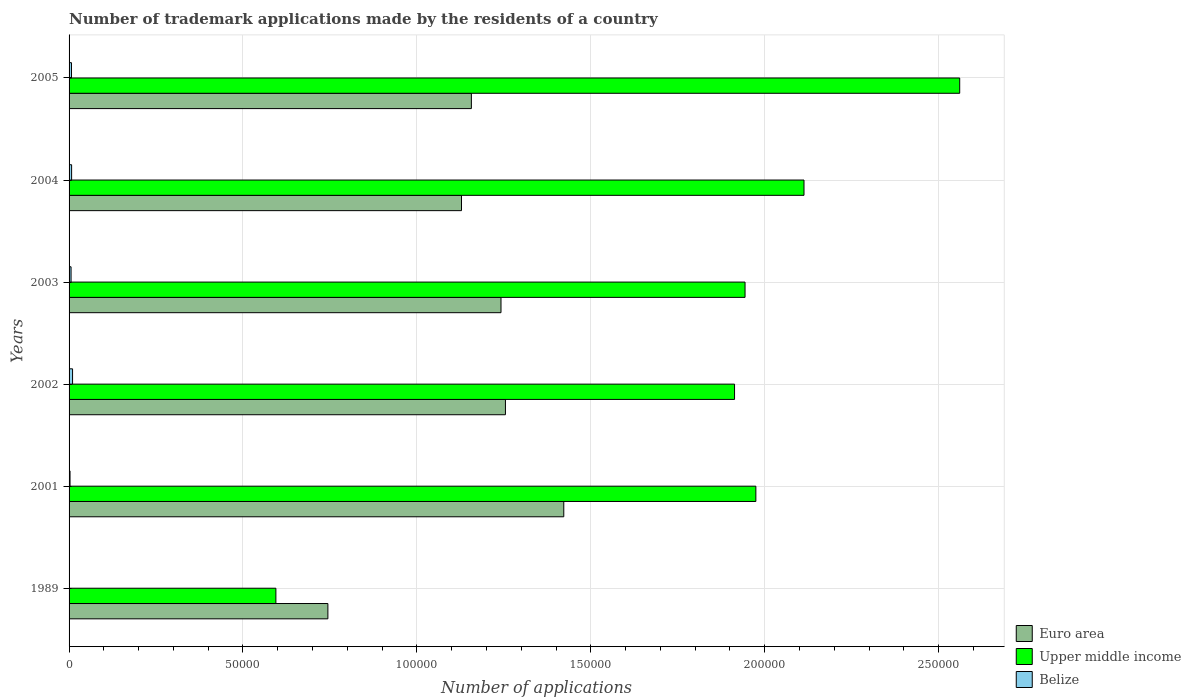How many different coloured bars are there?
Give a very brief answer. 3. How many groups of bars are there?
Keep it short and to the point. 6. Are the number of bars per tick equal to the number of legend labels?
Offer a very short reply. Yes. How many bars are there on the 4th tick from the bottom?
Ensure brevity in your answer.  3. What is the label of the 4th group of bars from the top?
Provide a short and direct response. 2002. In how many cases, is the number of bars for a given year not equal to the number of legend labels?
Provide a short and direct response. 0. What is the number of trademark applications made by the residents in Belize in 2002?
Your answer should be very brief. 1002. Across all years, what is the maximum number of trademark applications made by the residents in Upper middle income?
Your answer should be very brief. 2.56e+05. Across all years, what is the minimum number of trademark applications made by the residents in Euro area?
Ensure brevity in your answer.  7.44e+04. In which year was the number of trademark applications made by the residents in Belize maximum?
Your answer should be compact. 2002. In which year was the number of trademark applications made by the residents in Euro area minimum?
Offer a terse response. 1989. What is the total number of trademark applications made by the residents in Belize in the graph?
Give a very brief answer. 3315. What is the difference between the number of trademark applications made by the residents in Euro area in 2004 and that in 2005?
Keep it short and to the point. -2840. What is the difference between the number of trademark applications made by the residents in Euro area in 1989 and the number of trademark applications made by the residents in Belize in 2001?
Your answer should be very brief. 7.41e+04. What is the average number of trademark applications made by the residents in Belize per year?
Make the answer very short. 552.5. In the year 2002, what is the difference between the number of trademark applications made by the residents in Upper middle income and number of trademark applications made by the residents in Belize?
Ensure brevity in your answer.  1.90e+05. What is the ratio of the number of trademark applications made by the residents in Belize in 1989 to that in 2003?
Give a very brief answer. 0.07. What is the difference between the highest and the second highest number of trademark applications made by the residents in Upper middle income?
Offer a very short reply. 4.48e+04. What is the difference between the highest and the lowest number of trademark applications made by the residents in Upper middle income?
Give a very brief answer. 1.97e+05. What does the 1st bar from the top in 2004 represents?
Offer a very short reply. Belize. What does the 3rd bar from the bottom in 2004 represents?
Give a very brief answer. Belize. Is it the case that in every year, the sum of the number of trademark applications made by the residents in Belize and number of trademark applications made by the residents in Upper middle income is greater than the number of trademark applications made by the residents in Euro area?
Your answer should be compact. No. What is the difference between two consecutive major ticks on the X-axis?
Keep it short and to the point. 5.00e+04. Are the values on the major ticks of X-axis written in scientific E-notation?
Offer a terse response. No. Does the graph contain any zero values?
Offer a terse response. No. How many legend labels are there?
Provide a succinct answer. 3. What is the title of the graph?
Keep it short and to the point. Number of trademark applications made by the residents of a country. What is the label or title of the X-axis?
Give a very brief answer. Number of applications. What is the label or title of the Y-axis?
Offer a terse response. Years. What is the Number of applications of Euro area in 1989?
Provide a short and direct response. 7.44e+04. What is the Number of applications of Upper middle income in 1989?
Offer a terse response. 5.95e+04. What is the Number of applications of Euro area in 2001?
Provide a short and direct response. 1.42e+05. What is the Number of applications in Upper middle income in 2001?
Offer a very short reply. 1.97e+05. What is the Number of applications of Belize in 2001?
Your answer should be very brief. 277. What is the Number of applications of Euro area in 2002?
Offer a very short reply. 1.25e+05. What is the Number of applications of Upper middle income in 2002?
Give a very brief answer. 1.91e+05. What is the Number of applications in Belize in 2002?
Offer a very short reply. 1002. What is the Number of applications of Euro area in 2003?
Your response must be concise. 1.24e+05. What is the Number of applications in Upper middle income in 2003?
Give a very brief answer. 1.94e+05. What is the Number of applications of Belize in 2003?
Your answer should be compact. 573. What is the Number of applications in Euro area in 2004?
Provide a short and direct response. 1.13e+05. What is the Number of applications of Upper middle income in 2004?
Your answer should be very brief. 2.11e+05. What is the Number of applications of Belize in 2004?
Your response must be concise. 732. What is the Number of applications in Euro area in 2005?
Provide a short and direct response. 1.16e+05. What is the Number of applications of Upper middle income in 2005?
Provide a succinct answer. 2.56e+05. What is the Number of applications of Belize in 2005?
Provide a short and direct response. 693. Across all years, what is the maximum Number of applications in Euro area?
Provide a succinct answer. 1.42e+05. Across all years, what is the maximum Number of applications of Upper middle income?
Make the answer very short. 2.56e+05. Across all years, what is the maximum Number of applications in Belize?
Make the answer very short. 1002. Across all years, what is the minimum Number of applications in Euro area?
Make the answer very short. 7.44e+04. Across all years, what is the minimum Number of applications in Upper middle income?
Your answer should be very brief. 5.95e+04. What is the total Number of applications in Euro area in the graph?
Keep it short and to the point. 6.95e+05. What is the total Number of applications in Upper middle income in the graph?
Your answer should be compact. 1.11e+06. What is the total Number of applications in Belize in the graph?
Offer a very short reply. 3315. What is the difference between the Number of applications of Euro area in 1989 and that in 2001?
Offer a very short reply. -6.78e+04. What is the difference between the Number of applications of Upper middle income in 1989 and that in 2001?
Provide a succinct answer. -1.38e+05. What is the difference between the Number of applications in Belize in 1989 and that in 2001?
Keep it short and to the point. -239. What is the difference between the Number of applications of Euro area in 1989 and that in 2002?
Give a very brief answer. -5.10e+04. What is the difference between the Number of applications of Upper middle income in 1989 and that in 2002?
Offer a terse response. -1.32e+05. What is the difference between the Number of applications in Belize in 1989 and that in 2002?
Your answer should be very brief. -964. What is the difference between the Number of applications of Euro area in 1989 and that in 2003?
Ensure brevity in your answer.  -4.98e+04. What is the difference between the Number of applications of Upper middle income in 1989 and that in 2003?
Your answer should be compact. -1.35e+05. What is the difference between the Number of applications in Belize in 1989 and that in 2003?
Your response must be concise. -535. What is the difference between the Number of applications of Euro area in 1989 and that in 2004?
Ensure brevity in your answer.  -3.84e+04. What is the difference between the Number of applications of Upper middle income in 1989 and that in 2004?
Offer a terse response. -1.52e+05. What is the difference between the Number of applications of Belize in 1989 and that in 2004?
Ensure brevity in your answer.  -694. What is the difference between the Number of applications in Euro area in 1989 and that in 2005?
Make the answer very short. -4.13e+04. What is the difference between the Number of applications in Upper middle income in 1989 and that in 2005?
Your answer should be very brief. -1.97e+05. What is the difference between the Number of applications in Belize in 1989 and that in 2005?
Give a very brief answer. -655. What is the difference between the Number of applications in Euro area in 2001 and that in 2002?
Provide a short and direct response. 1.68e+04. What is the difference between the Number of applications of Upper middle income in 2001 and that in 2002?
Give a very brief answer. 6129. What is the difference between the Number of applications in Belize in 2001 and that in 2002?
Provide a short and direct response. -725. What is the difference between the Number of applications of Euro area in 2001 and that in 2003?
Provide a succinct answer. 1.80e+04. What is the difference between the Number of applications in Upper middle income in 2001 and that in 2003?
Make the answer very short. 3108. What is the difference between the Number of applications in Belize in 2001 and that in 2003?
Your answer should be very brief. -296. What is the difference between the Number of applications in Euro area in 2001 and that in 2004?
Your answer should be compact. 2.94e+04. What is the difference between the Number of applications of Upper middle income in 2001 and that in 2004?
Ensure brevity in your answer.  -1.38e+04. What is the difference between the Number of applications of Belize in 2001 and that in 2004?
Your response must be concise. -455. What is the difference between the Number of applications of Euro area in 2001 and that in 2005?
Provide a short and direct response. 2.66e+04. What is the difference between the Number of applications of Upper middle income in 2001 and that in 2005?
Your response must be concise. -5.86e+04. What is the difference between the Number of applications in Belize in 2001 and that in 2005?
Your answer should be compact. -416. What is the difference between the Number of applications of Euro area in 2002 and that in 2003?
Your response must be concise. 1276. What is the difference between the Number of applications in Upper middle income in 2002 and that in 2003?
Your answer should be compact. -3021. What is the difference between the Number of applications in Belize in 2002 and that in 2003?
Offer a terse response. 429. What is the difference between the Number of applications in Euro area in 2002 and that in 2004?
Provide a short and direct response. 1.26e+04. What is the difference between the Number of applications in Upper middle income in 2002 and that in 2004?
Provide a short and direct response. -2.00e+04. What is the difference between the Number of applications of Belize in 2002 and that in 2004?
Provide a short and direct response. 270. What is the difference between the Number of applications in Euro area in 2002 and that in 2005?
Provide a short and direct response. 9790. What is the difference between the Number of applications of Upper middle income in 2002 and that in 2005?
Give a very brief answer. -6.47e+04. What is the difference between the Number of applications in Belize in 2002 and that in 2005?
Offer a terse response. 309. What is the difference between the Number of applications of Euro area in 2003 and that in 2004?
Your answer should be compact. 1.14e+04. What is the difference between the Number of applications of Upper middle income in 2003 and that in 2004?
Provide a succinct answer. -1.69e+04. What is the difference between the Number of applications in Belize in 2003 and that in 2004?
Make the answer very short. -159. What is the difference between the Number of applications of Euro area in 2003 and that in 2005?
Provide a short and direct response. 8514. What is the difference between the Number of applications in Upper middle income in 2003 and that in 2005?
Your answer should be very brief. -6.17e+04. What is the difference between the Number of applications of Belize in 2003 and that in 2005?
Make the answer very short. -120. What is the difference between the Number of applications in Euro area in 2004 and that in 2005?
Provide a succinct answer. -2840. What is the difference between the Number of applications of Upper middle income in 2004 and that in 2005?
Ensure brevity in your answer.  -4.48e+04. What is the difference between the Number of applications of Belize in 2004 and that in 2005?
Give a very brief answer. 39. What is the difference between the Number of applications in Euro area in 1989 and the Number of applications in Upper middle income in 2001?
Offer a terse response. -1.23e+05. What is the difference between the Number of applications of Euro area in 1989 and the Number of applications of Belize in 2001?
Offer a terse response. 7.41e+04. What is the difference between the Number of applications of Upper middle income in 1989 and the Number of applications of Belize in 2001?
Ensure brevity in your answer.  5.92e+04. What is the difference between the Number of applications in Euro area in 1989 and the Number of applications in Upper middle income in 2002?
Keep it short and to the point. -1.17e+05. What is the difference between the Number of applications in Euro area in 1989 and the Number of applications in Belize in 2002?
Provide a succinct answer. 7.34e+04. What is the difference between the Number of applications of Upper middle income in 1989 and the Number of applications of Belize in 2002?
Give a very brief answer. 5.85e+04. What is the difference between the Number of applications of Euro area in 1989 and the Number of applications of Upper middle income in 2003?
Your answer should be compact. -1.20e+05. What is the difference between the Number of applications in Euro area in 1989 and the Number of applications in Belize in 2003?
Your response must be concise. 7.38e+04. What is the difference between the Number of applications of Upper middle income in 1989 and the Number of applications of Belize in 2003?
Your answer should be very brief. 5.89e+04. What is the difference between the Number of applications in Euro area in 1989 and the Number of applications in Upper middle income in 2004?
Your answer should be compact. -1.37e+05. What is the difference between the Number of applications in Euro area in 1989 and the Number of applications in Belize in 2004?
Offer a terse response. 7.37e+04. What is the difference between the Number of applications in Upper middle income in 1989 and the Number of applications in Belize in 2004?
Your answer should be very brief. 5.87e+04. What is the difference between the Number of applications of Euro area in 1989 and the Number of applications of Upper middle income in 2005?
Your answer should be very brief. -1.82e+05. What is the difference between the Number of applications of Euro area in 1989 and the Number of applications of Belize in 2005?
Offer a very short reply. 7.37e+04. What is the difference between the Number of applications of Upper middle income in 1989 and the Number of applications of Belize in 2005?
Your response must be concise. 5.88e+04. What is the difference between the Number of applications of Euro area in 2001 and the Number of applications of Upper middle income in 2002?
Ensure brevity in your answer.  -4.91e+04. What is the difference between the Number of applications of Euro area in 2001 and the Number of applications of Belize in 2002?
Give a very brief answer. 1.41e+05. What is the difference between the Number of applications of Upper middle income in 2001 and the Number of applications of Belize in 2002?
Your response must be concise. 1.96e+05. What is the difference between the Number of applications of Euro area in 2001 and the Number of applications of Upper middle income in 2003?
Make the answer very short. -5.21e+04. What is the difference between the Number of applications of Euro area in 2001 and the Number of applications of Belize in 2003?
Offer a terse response. 1.42e+05. What is the difference between the Number of applications in Upper middle income in 2001 and the Number of applications in Belize in 2003?
Offer a terse response. 1.97e+05. What is the difference between the Number of applications of Euro area in 2001 and the Number of applications of Upper middle income in 2004?
Offer a very short reply. -6.91e+04. What is the difference between the Number of applications in Euro area in 2001 and the Number of applications in Belize in 2004?
Your answer should be very brief. 1.41e+05. What is the difference between the Number of applications in Upper middle income in 2001 and the Number of applications in Belize in 2004?
Give a very brief answer. 1.97e+05. What is the difference between the Number of applications of Euro area in 2001 and the Number of applications of Upper middle income in 2005?
Offer a very short reply. -1.14e+05. What is the difference between the Number of applications of Euro area in 2001 and the Number of applications of Belize in 2005?
Offer a terse response. 1.42e+05. What is the difference between the Number of applications in Upper middle income in 2001 and the Number of applications in Belize in 2005?
Offer a very short reply. 1.97e+05. What is the difference between the Number of applications of Euro area in 2002 and the Number of applications of Upper middle income in 2003?
Provide a succinct answer. -6.89e+04. What is the difference between the Number of applications in Euro area in 2002 and the Number of applications in Belize in 2003?
Ensure brevity in your answer.  1.25e+05. What is the difference between the Number of applications in Upper middle income in 2002 and the Number of applications in Belize in 2003?
Give a very brief answer. 1.91e+05. What is the difference between the Number of applications of Euro area in 2002 and the Number of applications of Upper middle income in 2004?
Your answer should be compact. -8.58e+04. What is the difference between the Number of applications in Euro area in 2002 and the Number of applications in Belize in 2004?
Make the answer very short. 1.25e+05. What is the difference between the Number of applications in Upper middle income in 2002 and the Number of applications in Belize in 2004?
Give a very brief answer. 1.91e+05. What is the difference between the Number of applications in Euro area in 2002 and the Number of applications in Upper middle income in 2005?
Give a very brief answer. -1.31e+05. What is the difference between the Number of applications in Euro area in 2002 and the Number of applications in Belize in 2005?
Ensure brevity in your answer.  1.25e+05. What is the difference between the Number of applications in Upper middle income in 2002 and the Number of applications in Belize in 2005?
Your answer should be very brief. 1.91e+05. What is the difference between the Number of applications of Euro area in 2003 and the Number of applications of Upper middle income in 2004?
Provide a short and direct response. -8.71e+04. What is the difference between the Number of applications of Euro area in 2003 and the Number of applications of Belize in 2004?
Provide a short and direct response. 1.23e+05. What is the difference between the Number of applications in Upper middle income in 2003 and the Number of applications in Belize in 2004?
Provide a short and direct response. 1.94e+05. What is the difference between the Number of applications of Euro area in 2003 and the Number of applications of Upper middle income in 2005?
Make the answer very short. -1.32e+05. What is the difference between the Number of applications of Euro area in 2003 and the Number of applications of Belize in 2005?
Your answer should be very brief. 1.23e+05. What is the difference between the Number of applications in Upper middle income in 2003 and the Number of applications in Belize in 2005?
Your response must be concise. 1.94e+05. What is the difference between the Number of applications of Euro area in 2004 and the Number of applications of Upper middle income in 2005?
Ensure brevity in your answer.  -1.43e+05. What is the difference between the Number of applications of Euro area in 2004 and the Number of applications of Belize in 2005?
Ensure brevity in your answer.  1.12e+05. What is the difference between the Number of applications in Upper middle income in 2004 and the Number of applications in Belize in 2005?
Your response must be concise. 2.11e+05. What is the average Number of applications of Euro area per year?
Your answer should be very brief. 1.16e+05. What is the average Number of applications in Upper middle income per year?
Ensure brevity in your answer.  1.85e+05. What is the average Number of applications of Belize per year?
Your answer should be compact. 552.5. In the year 1989, what is the difference between the Number of applications of Euro area and Number of applications of Upper middle income?
Keep it short and to the point. 1.49e+04. In the year 1989, what is the difference between the Number of applications in Euro area and Number of applications in Belize?
Your answer should be compact. 7.44e+04. In the year 1989, what is the difference between the Number of applications in Upper middle income and Number of applications in Belize?
Give a very brief answer. 5.94e+04. In the year 2001, what is the difference between the Number of applications of Euro area and Number of applications of Upper middle income?
Your response must be concise. -5.52e+04. In the year 2001, what is the difference between the Number of applications of Euro area and Number of applications of Belize?
Your answer should be compact. 1.42e+05. In the year 2001, what is the difference between the Number of applications of Upper middle income and Number of applications of Belize?
Provide a short and direct response. 1.97e+05. In the year 2002, what is the difference between the Number of applications in Euro area and Number of applications in Upper middle income?
Ensure brevity in your answer.  -6.59e+04. In the year 2002, what is the difference between the Number of applications in Euro area and Number of applications in Belize?
Offer a very short reply. 1.24e+05. In the year 2002, what is the difference between the Number of applications of Upper middle income and Number of applications of Belize?
Provide a succinct answer. 1.90e+05. In the year 2003, what is the difference between the Number of applications in Euro area and Number of applications in Upper middle income?
Ensure brevity in your answer.  -7.02e+04. In the year 2003, what is the difference between the Number of applications of Euro area and Number of applications of Belize?
Your answer should be compact. 1.24e+05. In the year 2003, what is the difference between the Number of applications in Upper middle income and Number of applications in Belize?
Offer a very short reply. 1.94e+05. In the year 2004, what is the difference between the Number of applications in Euro area and Number of applications in Upper middle income?
Give a very brief answer. -9.85e+04. In the year 2004, what is the difference between the Number of applications in Euro area and Number of applications in Belize?
Offer a terse response. 1.12e+05. In the year 2004, what is the difference between the Number of applications of Upper middle income and Number of applications of Belize?
Give a very brief answer. 2.11e+05. In the year 2005, what is the difference between the Number of applications in Euro area and Number of applications in Upper middle income?
Ensure brevity in your answer.  -1.40e+05. In the year 2005, what is the difference between the Number of applications of Euro area and Number of applications of Belize?
Your response must be concise. 1.15e+05. In the year 2005, what is the difference between the Number of applications in Upper middle income and Number of applications in Belize?
Ensure brevity in your answer.  2.55e+05. What is the ratio of the Number of applications of Euro area in 1989 to that in 2001?
Your answer should be very brief. 0.52. What is the ratio of the Number of applications of Upper middle income in 1989 to that in 2001?
Your response must be concise. 0.3. What is the ratio of the Number of applications of Belize in 1989 to that in 2001?
Offer a terse response. 0.14. What is the ratio of the Number of applications of Euro area in 1989 to that in 2002?
Give a very brief answer. 0.59. What is the ratio of the Number of applications in Upper middle income in 1989 to that in 2002?
Your response must be concise. 0.31. What is the ratio of the Number of applications of Belize in 1989 to that in 2002?
Provide a succinct answer. 0.04. What is the ratio of the Number of applications in Euro area in 1989 to that in 2003?
Ensure brevity in your answer.  0.6. What is the ratio of the Number of applications in Upper middle income in 1989 to that in 2003?
Your response must be concise. 0.31. What is the ratio of the Number of applications in Belize in 1989 to that in 2003?
Your response must be concise. 0.07. What is the ratio of the Number of applications of Euro area in 1989 to that in 2004?
Give a very brief answer. 0.66. What is the ratio of the Number of applications in Upper middle income in 1989 to that in 2004?
Keep it short and to the point. 0.28. What is the ratio of the Number of applications of Belize in 1989 to that in 2004?
Offer a terse response. 0.05. What is the ratio of the Number of applications of Euro area in 1989 to that in 2005?
Provide a short and direct response. 0.64. What is the ratio of the Number of applications of Upper middle income in 1989 to that in 2005?
Your response must be concise. 0.23. What is the ratio of the Number of applications of Belize in 1989 to that in 2005?
Provide a succinct answer. 0.05. What is the ratio of the Number of applications in Euro area in 2001 to that in 2002?
Provide a short and direct response. 1.13. What is the ratio of the Number of applications of Upper middle income in 2001 to that in 2002?
Make the answer very short. 1.03. What is the ratio of the Number of applications of Belize in 2001 to that in 2002?
Keep it short and to the point. 0.28. What is the ratio of the Number of applications of Euro area in 2001 to that in 2003?
Your answer should be very brief. 1.15. What is the ratio of the Number of applications of Belize in 2001 to that in 2003?
Keep it short and to the point. 0.48. What is the ratio of the Number of applications in Euro area in 2001 to that in 2004?
Provide a succinct answer. 1.26. What is the ratio of the Number of applications in Upper middle income in 2001 to that in 2004?
Offer a very short reply. 0.93. What is the ratio of the Number of applications of Belize in 2001 to that in 2004?
Provide a succinct answer. 0.38. What is the ratio of the Number of applications in Euro area in 2001 to that in 2005?
Provide a short and direct response. 1.23. What is the ratio of the Number of applications of Upper middle income in 2001 to that in 2005?
Your answer should be very brief. 0.77. What is the ratio of the Number of applications in Belize in 2001 to that in 2005?
Your response must be concise. 0.4. What is the ratio of the Number of applications in Euro area in 2002 to that in 2003?
Provide a succinct answer. 1.01. What is the ratio of the Number of applications in Upper middle income in 2002 to that in 2003?
Keep it short and to the point. 0.98. What is the ratio of the Number of applications in Belize in 2002 to that in 2003?
Offer a very short reply. 1.75. What is the ratio of the Number of applications in Euro area in 2002 to that in 2004?
Make the answer very short. 1.11. What is the ratio of the Number of applications of Upper middle income in 2002 to that in 2004?
Ensure brevity in your answer.  0.91. What is the ratio of the Number of applications of Belize in 2002 to that in 2004?
Keep it short and to the point. 1.37. What is the ratio of the Number of applications of Euro area in 2002 to that in 2005?
Your response must be concise. 1.08. What is the ratio of the Number of applications of Upper middle income in 2002 to that in 2005?
Provide a succinct answer. 0.75. What is the ratio of the Number of applications in Belize in 2002 to that in 2005?
Your answer should be compact. 1.45. What is the ratio of the Number of applications of Euro area in 2003 to that in 2004?
Make the answer very short. 1.1. What is the ratio of the Number of applications of Upper middle income in 2003 to that in 2004?
Offer a terse response. 0.92. What is the ratio of the Number of applications of Belize in 2003 to that in 2004?
Your answer should be compact. 0.78. What is the ratio of the Number of applications in Euro area in 2003 to that in 2005?
Provide a short and direct response. 1.07. What is the ratio of the Number of applications of Upper middle income in 2003 to that in 2005?
Provide a succinct answer. 0.76. What is the ratio of the Number of applications of Belize in 2003 to that in 2005?
Give a very brief answer. 0.83. What is the ratio of the Number of applications of Euro area in 2004 to that in 2005?
Your answer should be compact. 0.98. What is the ratio of the Number of applications of Upper middle income in 2004 to that in 2005?
Make the answer very short. 0.83. What is the ratio of the Number of applications of Belize in 2004 to that in 2005?
Provide a succinct answer. 1.06. What is the difference between the highest and the second highest Number of applications of Euro area?
Make the answer very short. 1.68e+04. What is the difference between the highest and the second highest Number of applications in Upper middle income?
Give a very brief answer. 4.48e+04. What is the difference between the highest and the second highest Number of applications in Belize?
Ensure brevity in your answer.  270. What is the difference between the highest and the lowest Number of applications in Euro area?
Give a very brief answer. 6.78e+04. What is the difference between the highest and the lowest Number of applications in Upper middle income?
Provide a succinct answer. 1.97e+05. What is the difference between the highest and the lowest Number of applications of Belize?
Offer a very short reply. 964. 